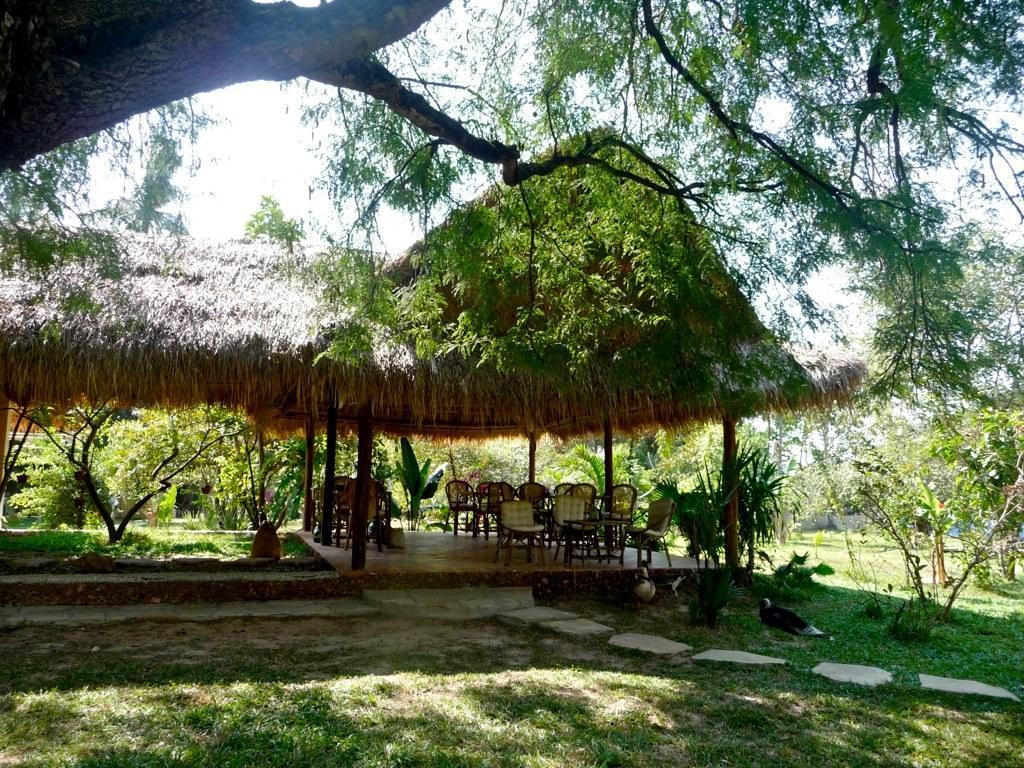Please provide a concise description of this image. In this image I can see few chairs in cream and brown color. Background I can see few plants and trees in green color, and sky is in white color. 